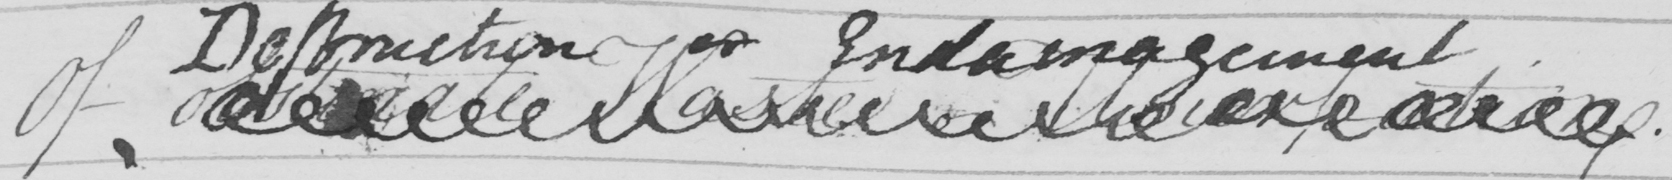Please provide the text content of this handwritten line. Of obstinate Waste or Usurpation . 